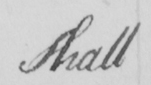Can you read and transcribe this handwriting? shall 